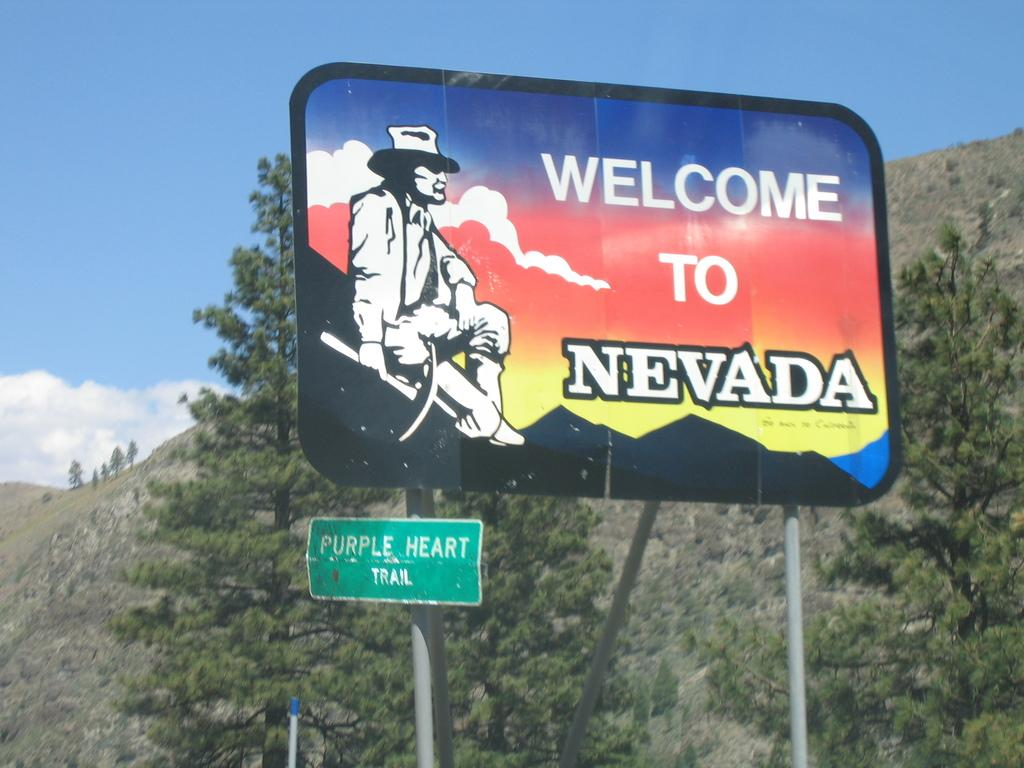Provide a one-sentence caption for the provided image. A hilly landscape with a large sign that says Welcome To Nevada. 